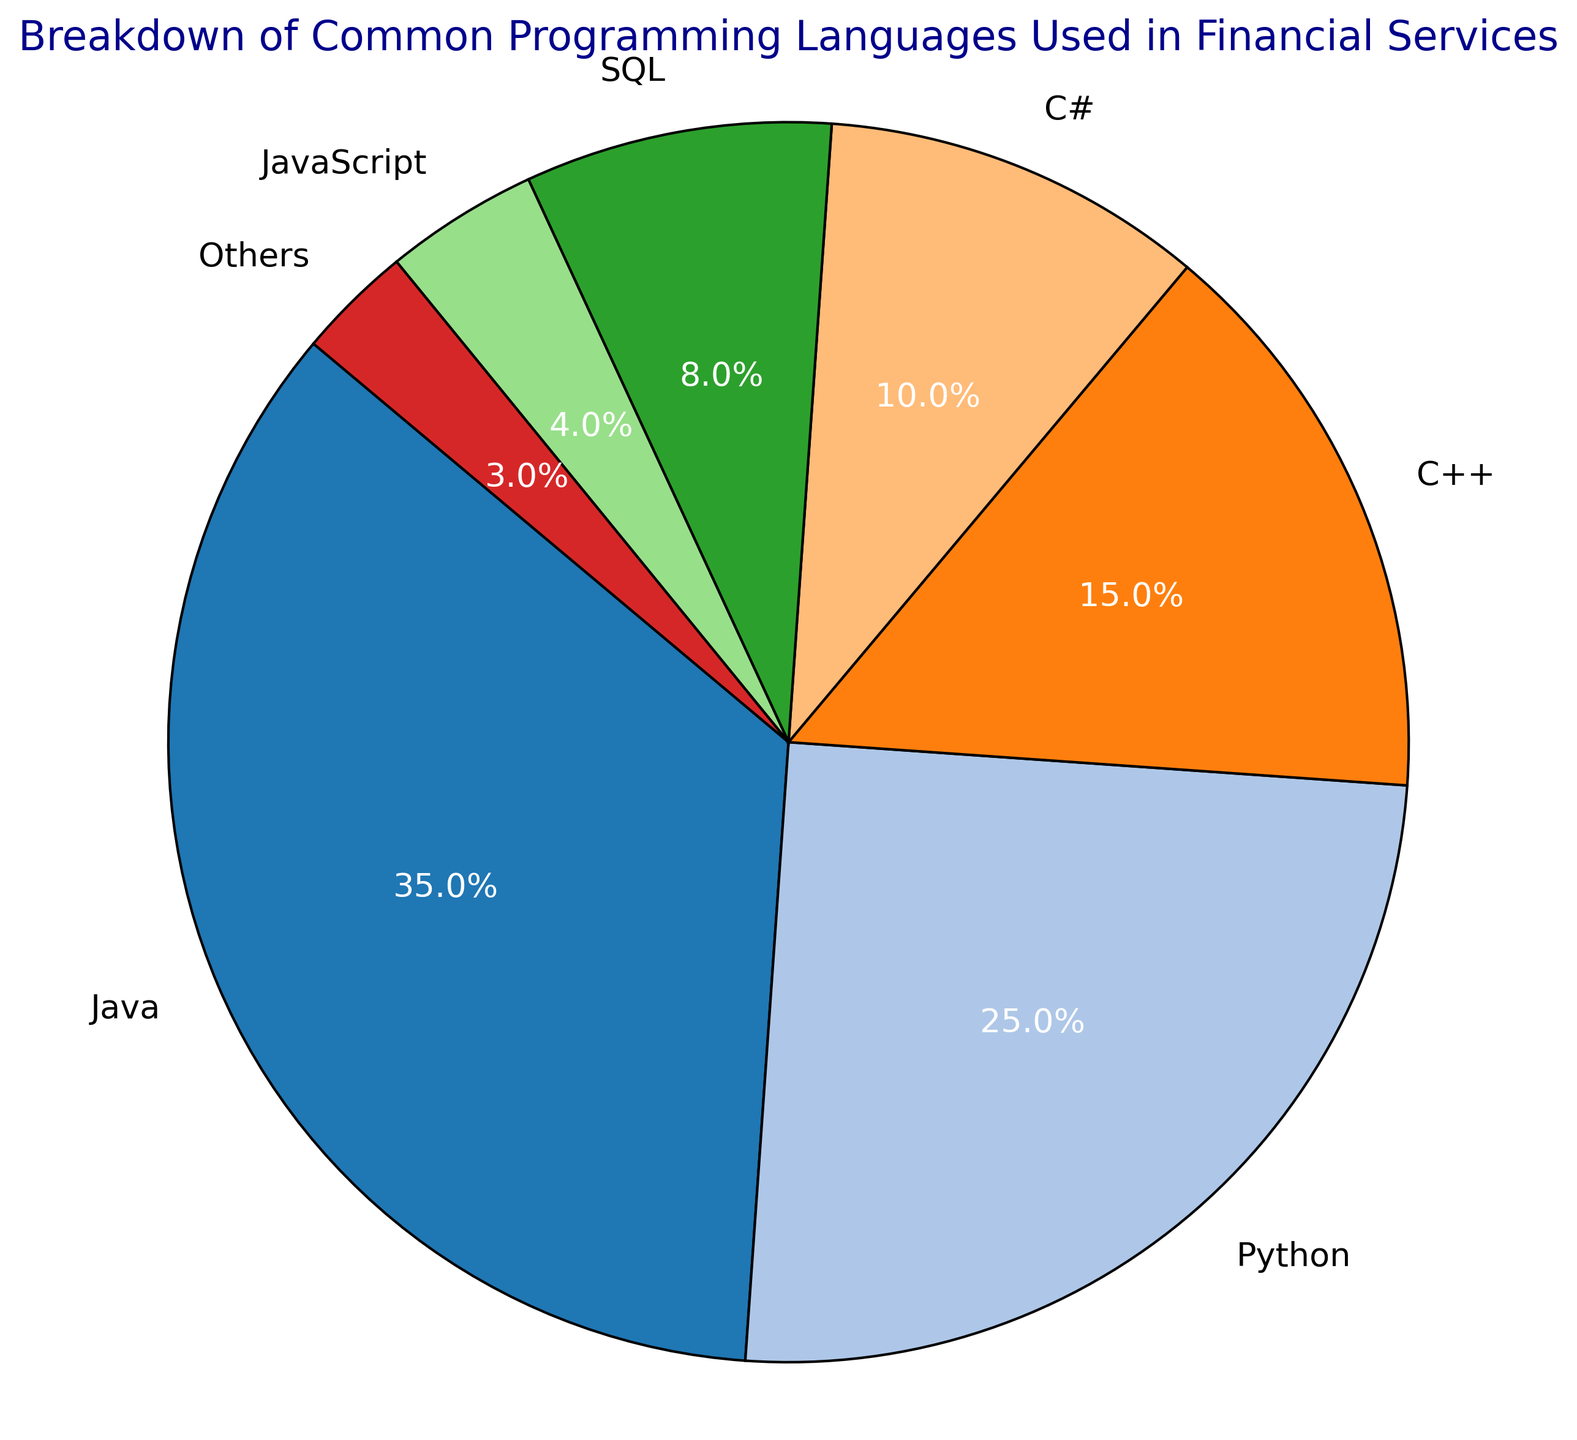What percentage of financial services use Java and C++ combined? Sum the percentages for Java (35%) and C++ (15%). 35% + 15% = 50%
Answer: 50% Which language has the lowest usage percentage? Identify the language with the smallest percentage in the data, which is "Others" with 3%.
Answer: Others Is Python usage greater than the combined usage of SQL and JavaScript? Compare Python's percentage (25%) with the sum of SQL (8%) and JavaScript (4%). Python's usage is 25%, while combined SQL and JavaScript usage is 8% + 4% = 12%. 25% is greater than 12%.
Answer: Yes How much more is the usage of Java compared to C# in percentage points? Subtract the usage percentage of C# (10%) from the usage percentage of Java (35%). 35% - 10% = 25%
Answer: 25% Between Python and C++, which language is used more and by what percentage difference? Subtract the usage of C++ (15%) from the usage of Python (25%). Python is used more. 25% - 15% = 10%
Answer: Python, by 10% What is the total percentage usage of languages that are below a 10% usage rate? Sum the percentages for C# (10%), SQL (8%), JavaScript (4%), and Others (3%). 10% + 8% + 4% + 3% = 25%
Answer: 25% Which language slice has the 3rd largest usage percentage, and what color is it? Identify the 3rd largest percentage slice in the data. The third largest is C++ at 15%, and based on its position, the color is the one assigned to C++ in the color scheme used.
Answer: C++, and its color What is the sum of the usage percentages for the top three languages? Identify the top three languages (Java: 35%, Python: 25%, C++: 15%) and sum their percentages. 35% + 25% + 15% = 75%
Answer: 75% Which two languages combined make up less usage than Python alone? Identify languages where their combined percentage is less than Python's (25%). SQL (8%) + JavaScript (4%) = 12%, which is less. Others (3%) + JavaScript (4%) = 7%, which is also less.
Answer: SQL and JavaScript; Others and JavaScript Which slices are colored most similarly, assuming the color gradient progresses logically from one color to the next? Visually inspect the color scheme to determine which neighboring slices appear similar. For instance, Java and Python or SQL and JavaScript might be close in color.
Answer: Depends on the color scheme, potentially Java and Python 